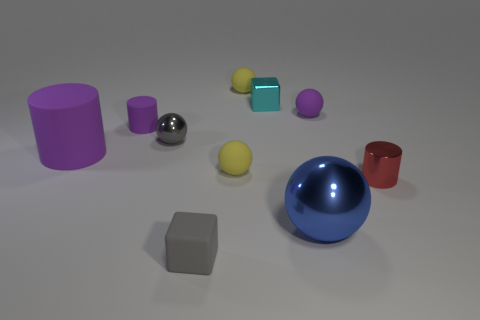Subtract all tiny metallic spheres. How many spheres are left? 4 Subtract all gray balls. How many balls are left? 4 Subtract all cyan balls. Subtract all cyan cubes. How many balls are left? 5 Subtract all cylinders. How many objects are left? 7 Subtract 0 brown balls. How many objects are left? 10 Subtract all big shiny objects. Subtract all big balls. How many objects are left? 8 Add 6 small rubber blocks. How many small rubber blocks are left? 7 Add 1 big brown blocks. How many big brown blocks exist? 1 